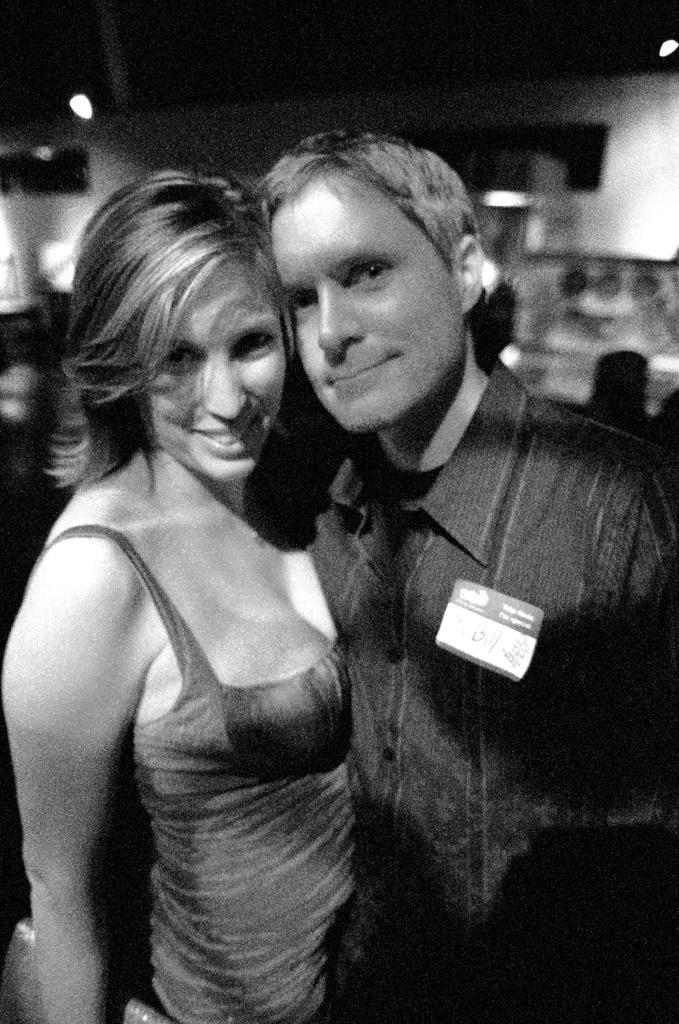How would you summarize this image in a sentence or two? In this picture there is a woman who is wearing grey dress, beside her we can see man who is wearing shirt and id card. In the background we can see group of person sitting on the chair. Here we can see lights. Here we can see bench. 